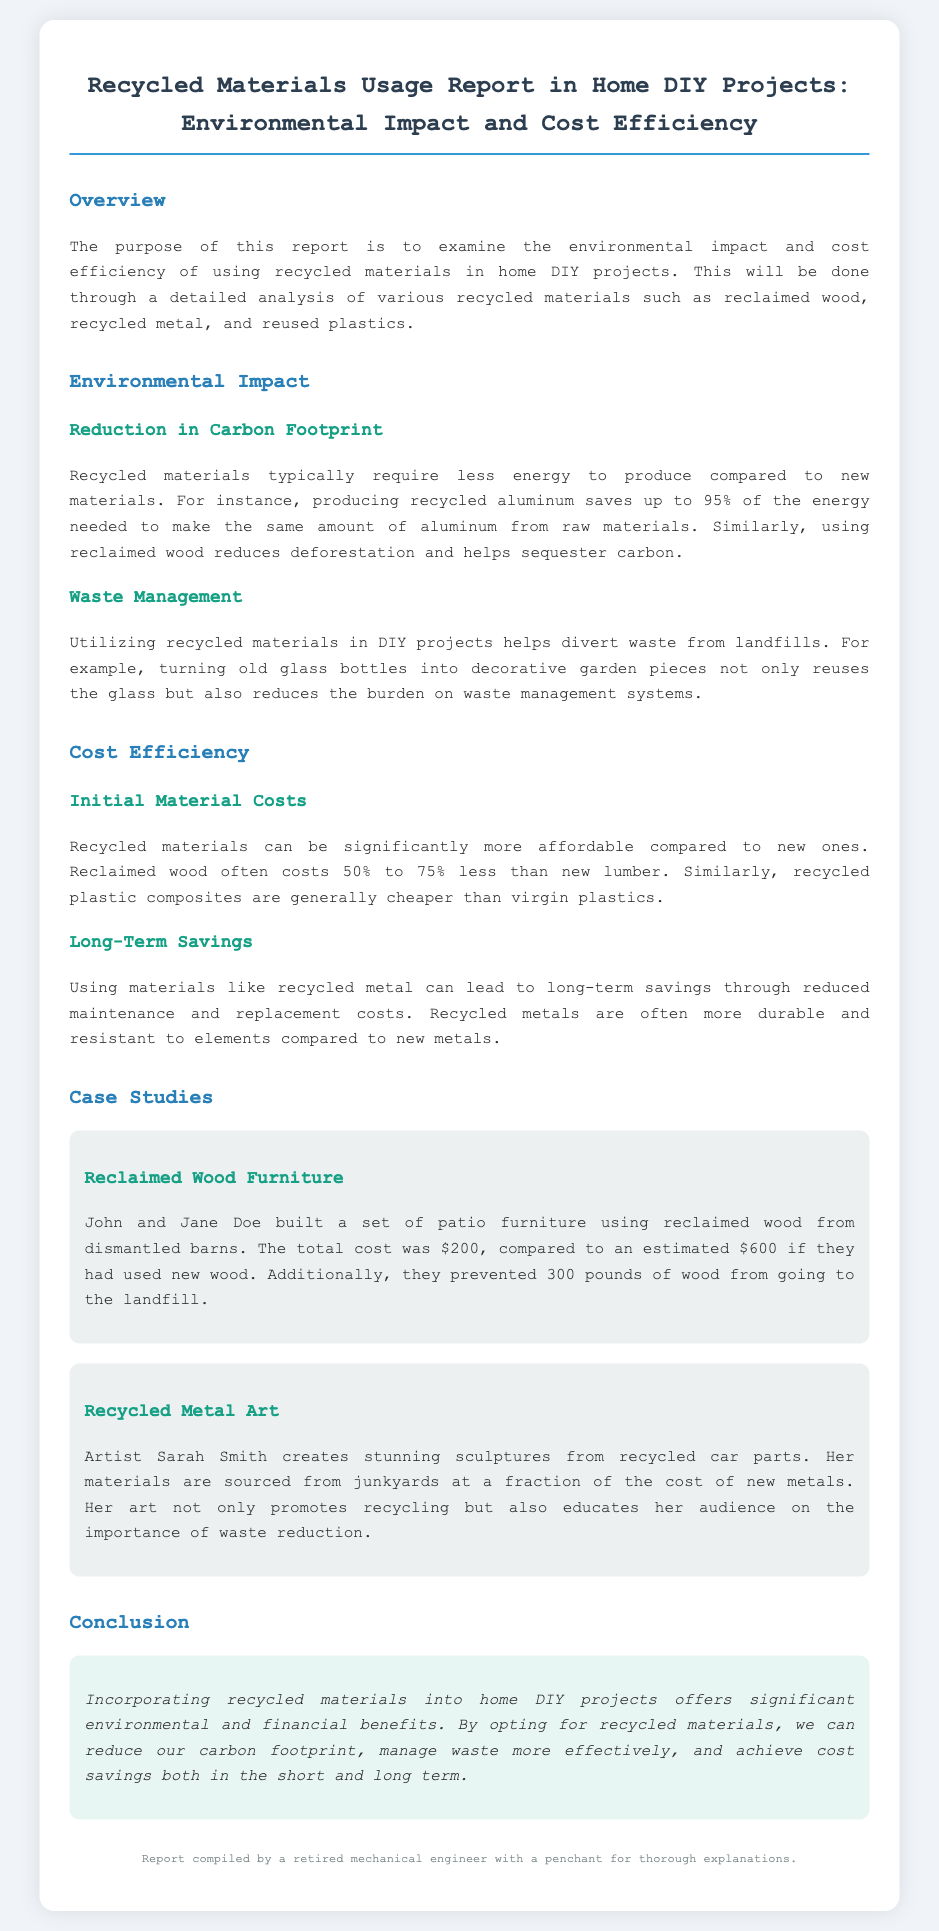what is the main purpose of the report? The report examines the environmental impact and cost efficiency of using recycled materials in home DIY projects.
Answer: examining the environmental impact and cost efficiency how much energy does producing recycled aluminum save? The report states that producing recycled aluminum saves up to 95% of the energy needed to make the same amount from raw materials.
Answer: 95% how much can reclaimed wood cost compared to new lumber? The report mentions that reclaimed wood often costs 50% to 75% less than new lumber.
Answer: 50% to 75% less what type of materials did John and Jane Doe use for their patio furniture? The case study states that they built furniture using reclaimed wood from dismantled barns.
Answer: reclaimed wood who creates sculptures from recycled car parts? The report highlights that artist Sarah Smith creates sculptures from recycled car parts.
Answer: Sarah Smith what is one benefit of using recycled metal mentioned in the report? The report indicates that using recycled metal can lead to long-term savings through reduced maintenance and replacement costs.
Answer: long-term savings what does the conclusion emphasize about using recycled materials? The conclusion emphasizes significant environmental and financial benefits when incorporating recycled materials into home DIY projects.
Answer: significant environmental and financial benefits 